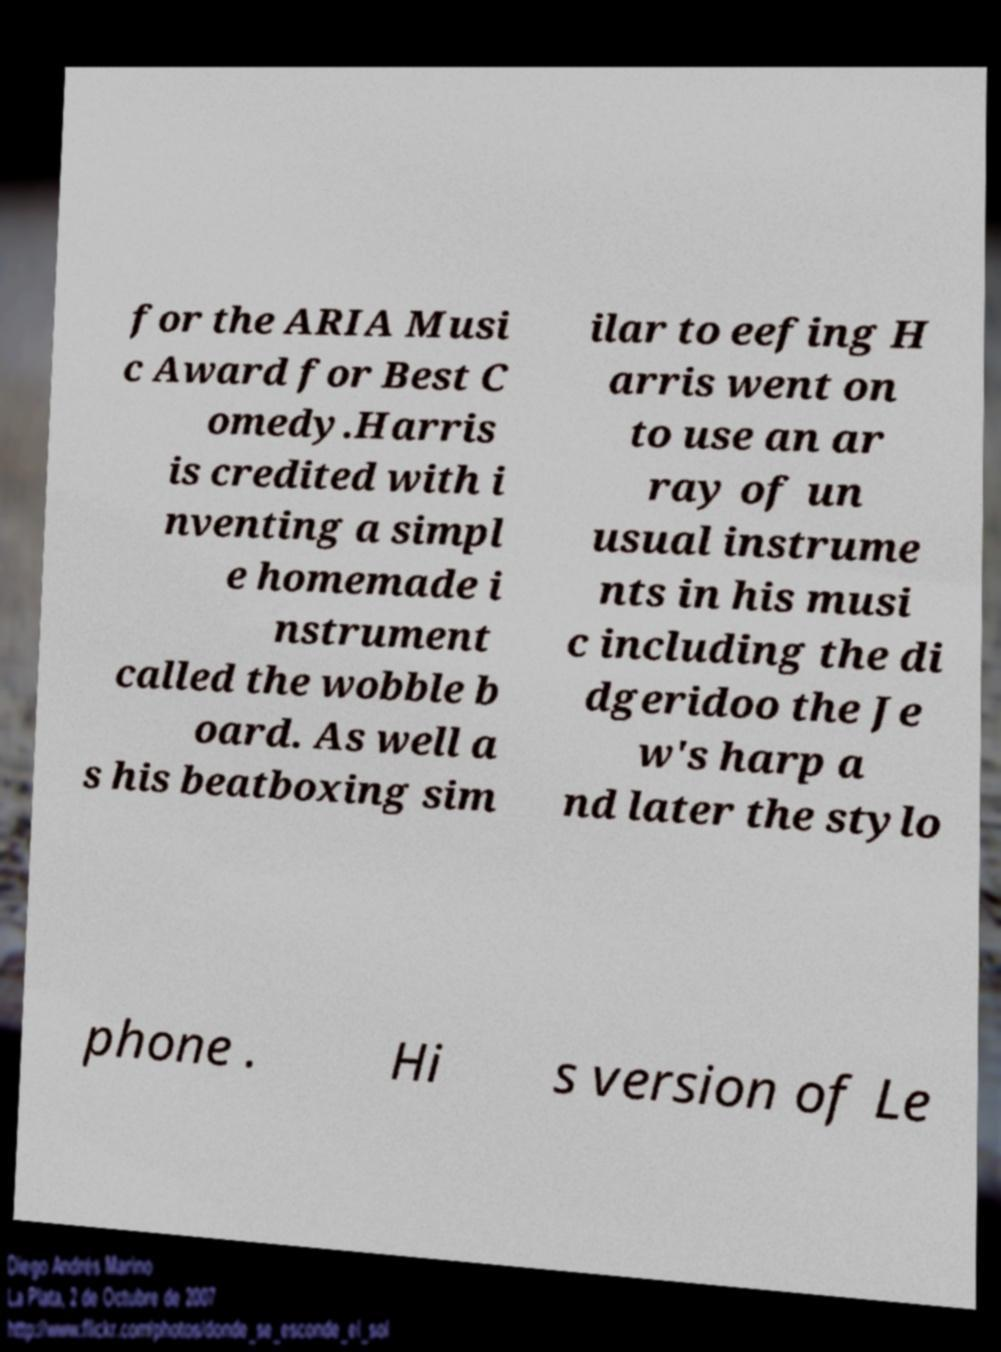There's text embedded in this image that I need extracted. Can you transcribe it verbatim? for the ARIA Musi c Award for Best C omedy.Harris is credited with i nventing a simpl e homemade i nstrument called the wobble b oard. As well a s his beatboxing sim ilar to eefing H arris went on to use an ar ray of un usual instrume nts in his musi c including the di dgeridoo the Je w's harp a nd later the stylo phone . Hi s version of Le 